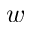Convert formula to latex. <formula><loc_0><loc_0><loc_500><loc_500>w</formula> 